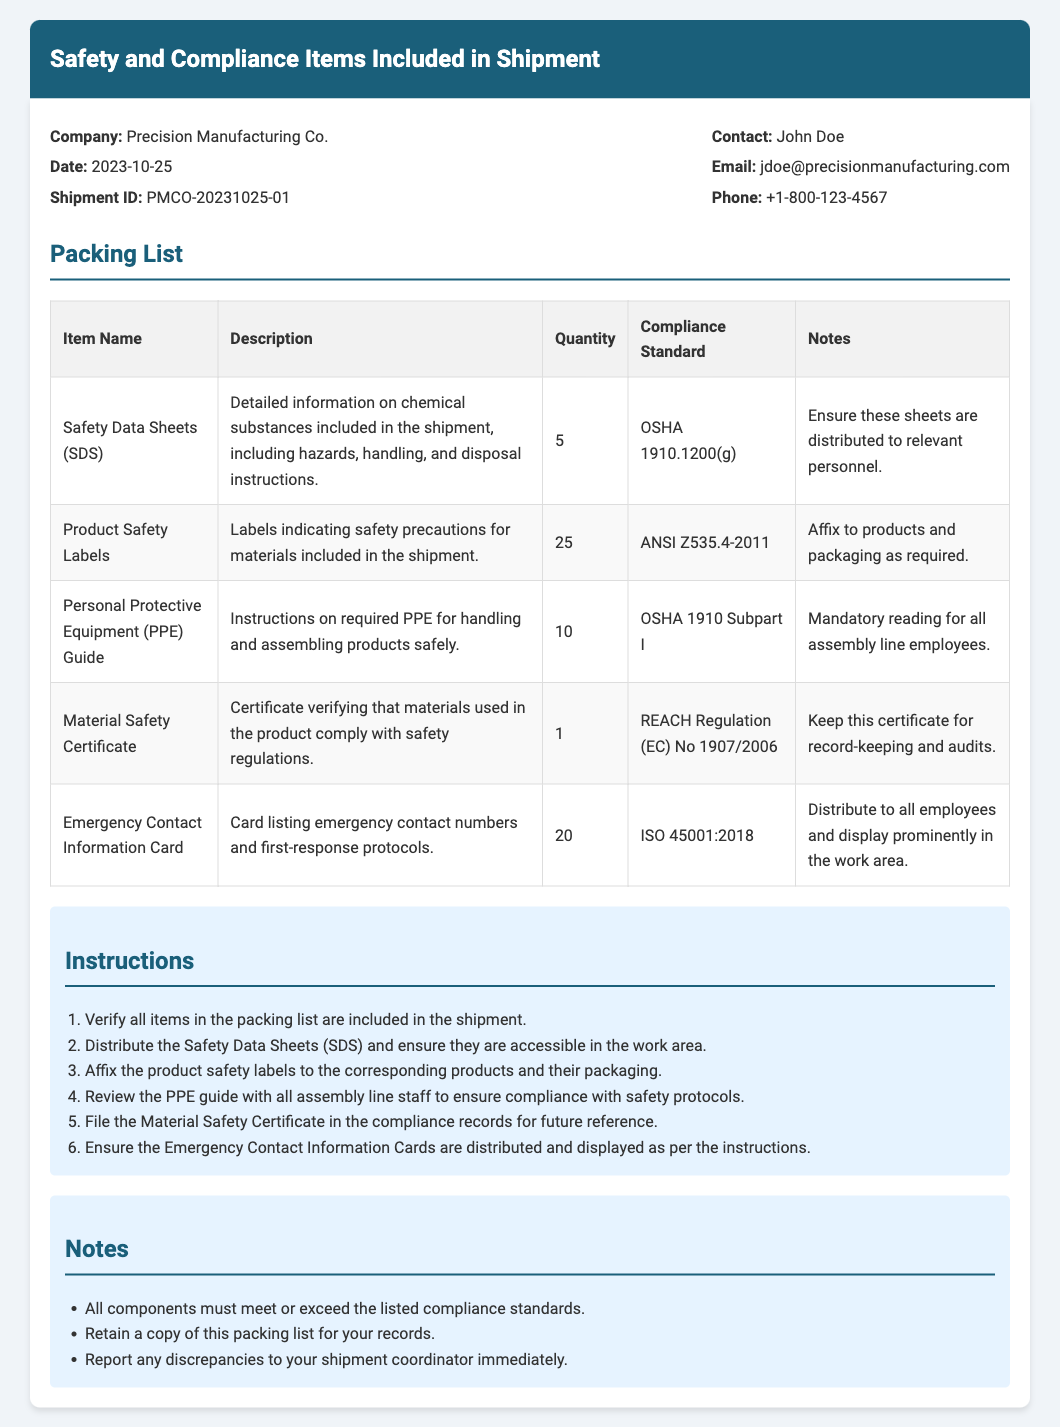What is the date of the shipment? The date of the shipment is provided in the document, specifically under the company information section, which states the date as 2023-10-25.
Answer: 2023-10-25 Who is the contact person for this shipment? The contact person is listed under the company information section of the document, which names John Doe.
Answer: John Doe How many Safety Data Sheets (SDS) are included? The quantity of Safety Data Sheets (SDS) is found in the packing list table, where it states that 5 SDS are included.
Answer: 5 What compliance standard is associated with the Personal Protective Equipment (PPE) Guide? The compliance standard for the PPE Guide is indicated in the packing list table as OSHA 1910 Subpart I.
Answer: OSHA 1910 Subpart I What should be done with the Material Safety Certificate? The instructions in the document specify that the Material Safety Certificate should be filed in the compliance records for future reference.
Answer: File in compliance records Why is it important to distribute the Emergency Contact Information Cards? The notes section indicates that distributing the Emergency Contact Information Cards is necessary for safety compliance as they must be displayed prominently in the work area.
Answer: Safety compliance What is the total quantity of Product Safety Labels included in the shipment? The total quantity is specified in the packing list table, indicating that 25 Product Safety Labels are included.
Answer: 25 What is the purpose of the instructions provided in the document? The instructions are detailed steps meant to ensure all compliance and safety items are properly handled and distributed according to the packing list.
Answer: Ensure proper handling and distribution 